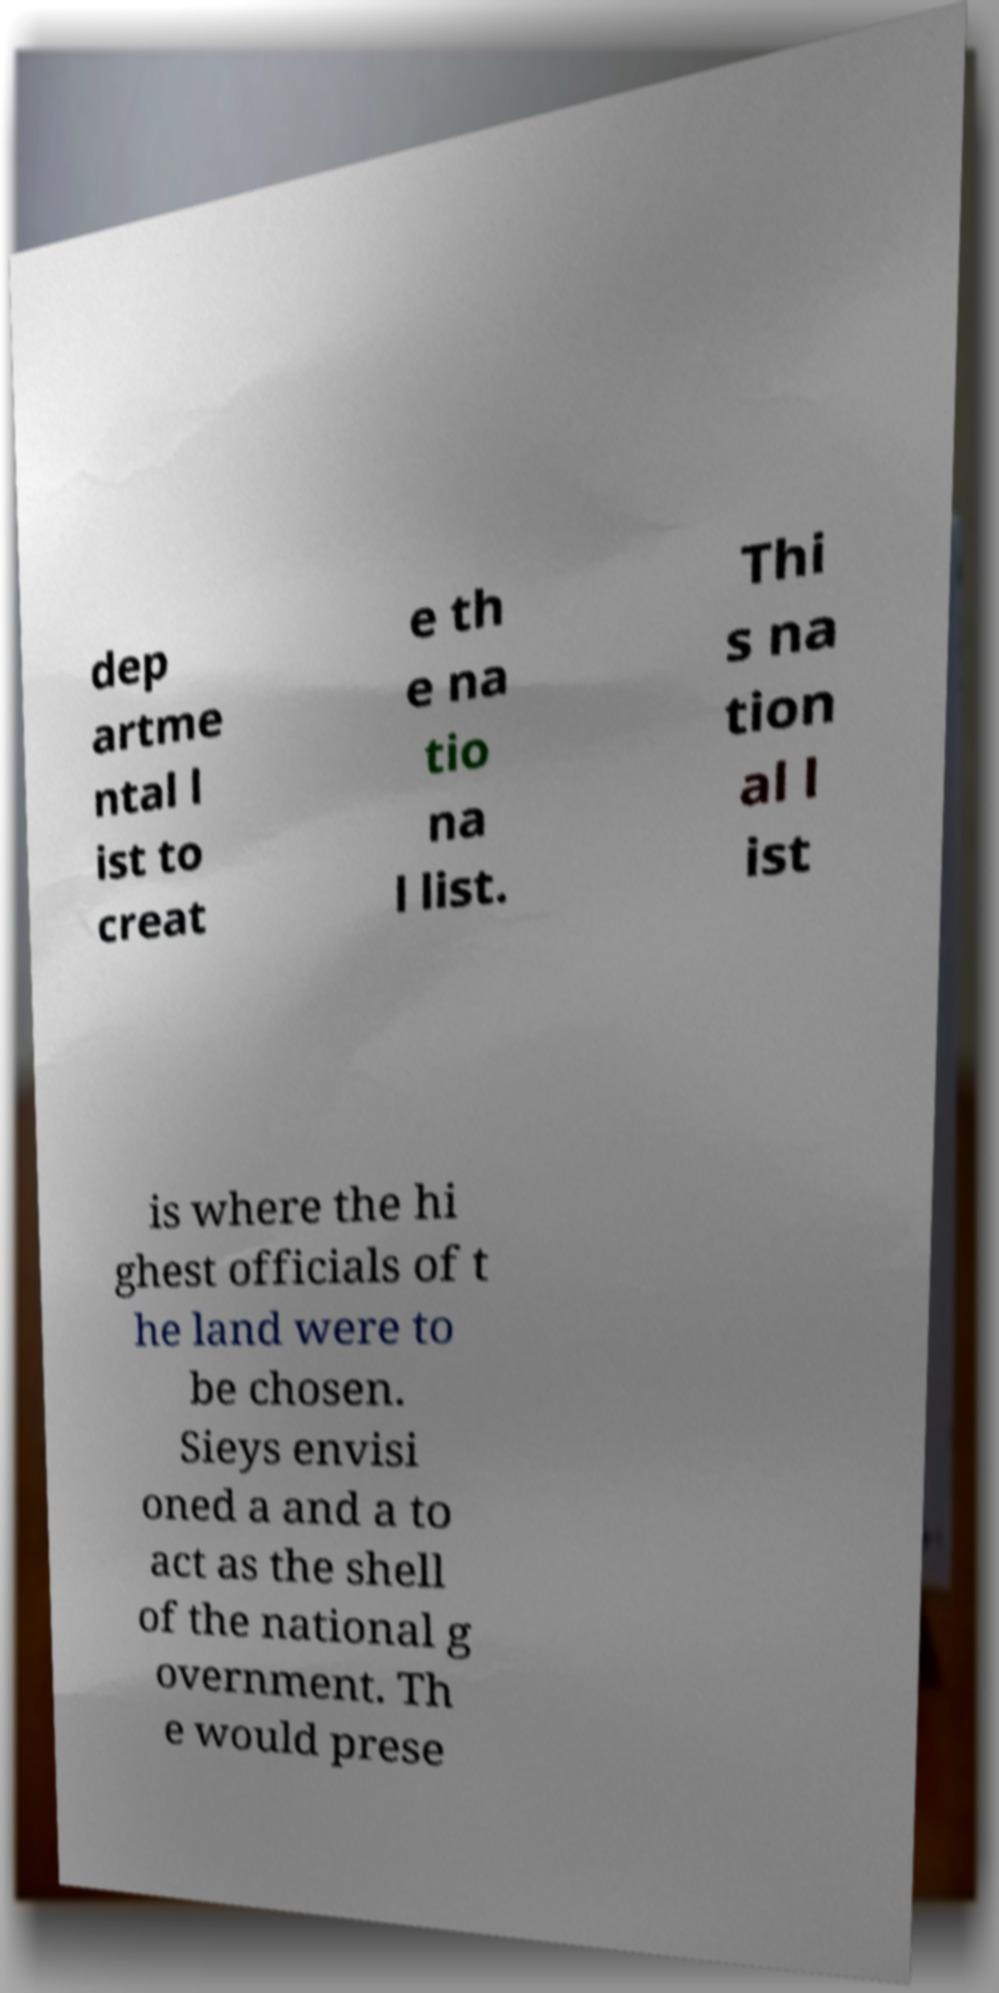Please identify and transcribe the text found in this image. dep artme ntal l ist to creat e th e na tio na l list. Thi s na tion al l ist is where the hi ghest officials of t he land were to be chosen. Sieys envisi oned a and a to act as the shell of the national g overnment. Th e would prese 